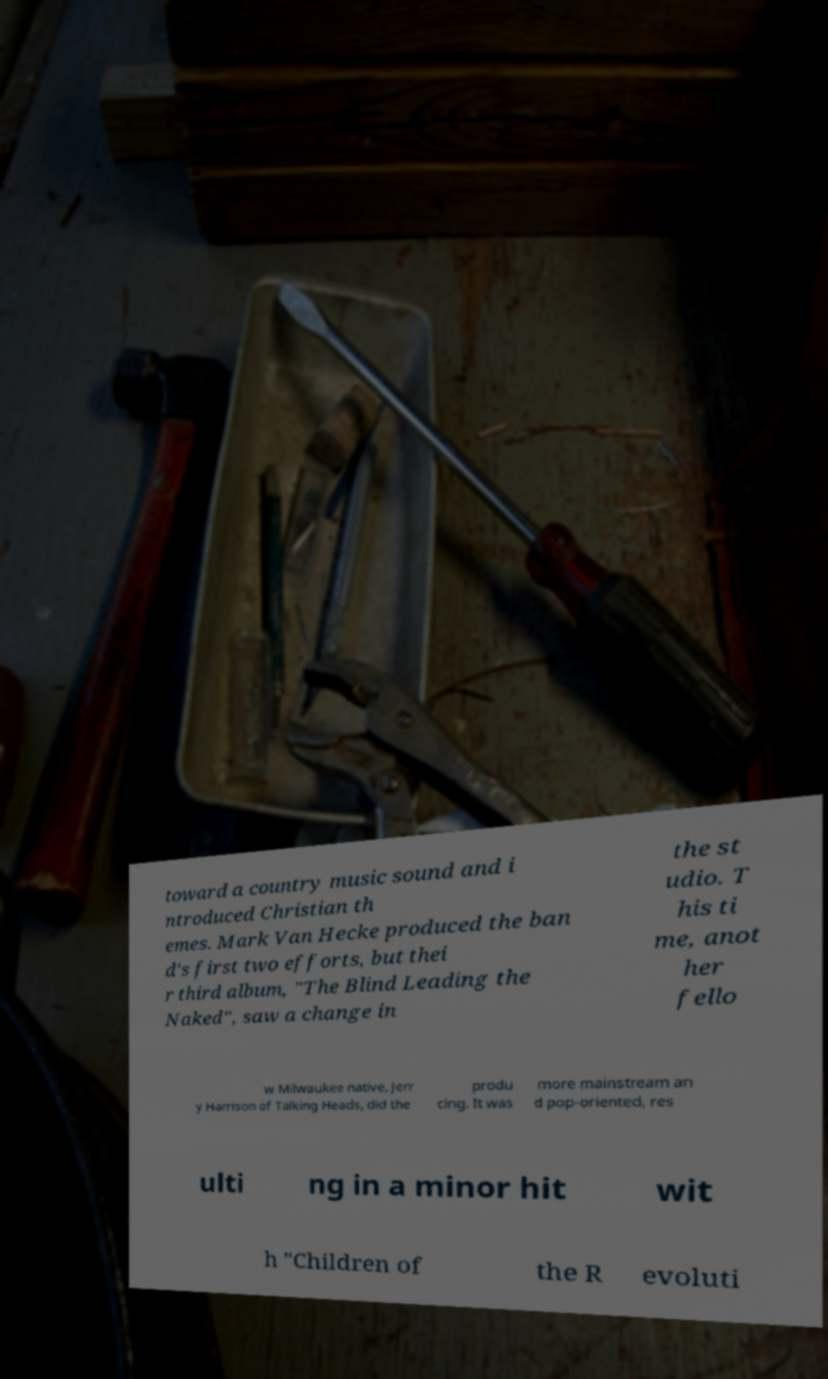Please identify and transcribe the text found in this image. toward a country music sound and i ntroduced Christian th emes. Mark Van Hecke produced the ban d's first two efforts, but thei r third album, "The Blind Leading the Naked", saw a change in the st udio. T his ti me, anot her fello w Milwaukee native, Jerr y Harrison of Talking Heads, did the produ cing. It was more mainstream an d pop-oriented, res ulti ng in a minor hit wit h "Children of the R evoluti 